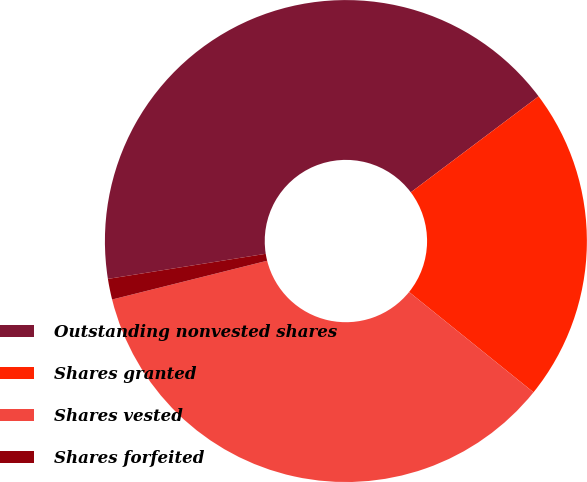Convert chart to OTSL. <chart><loc_0><loc_0><loc_500><loc_500><pie_chart><fcel>Outstanding nonvested shares<fcel>Shares granted<fcel>Shares vested<fcel>Shares forfeited<nl><fcel>42.26%<fcel>21.05%<fcel>35.3%<fcel>1.39%<nl></chart> 